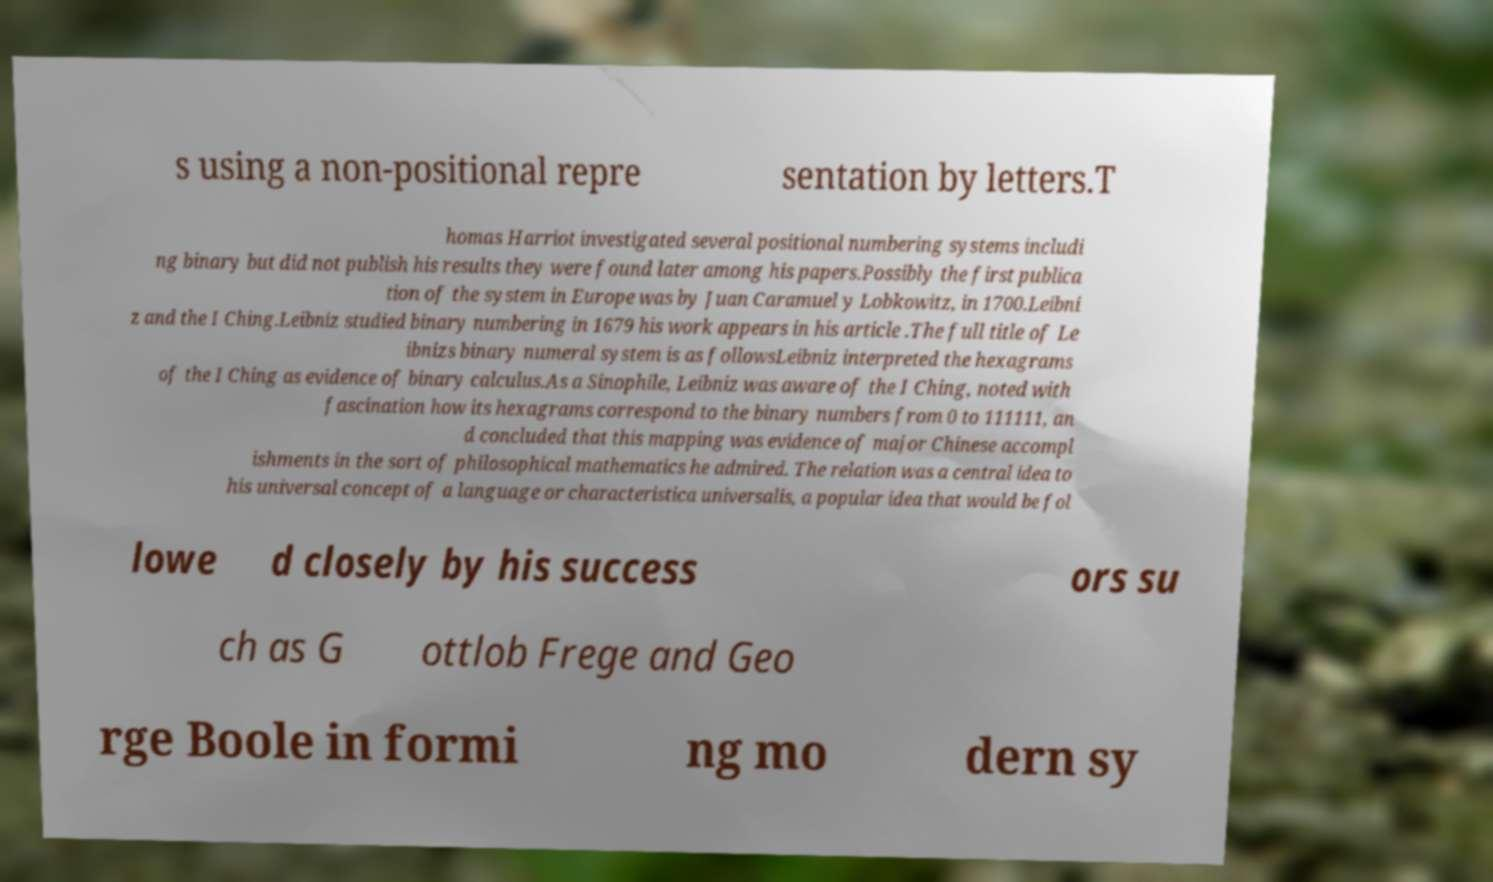Please read and relay the text visible in this image. What does it say? s using a non-positional repre sentation by letters.T homas Harriot investigated several positional numbering systems includi ng binary but did not publish his results they were found later among his papers.Possibly the first publica tion of the system in Europe was by Juan Caramuel y Lobkowitz, in 1700.Leibni z and the I Ching.Leibniz studied binary numbering in 1679 his work appears in his article .The full title of Le ibnizs binary numeral system is as followsLeibniz interpreted the hexagrams of the I Ching as evidence of binary calculus.As a Sinophile, Leibniz was aware of the I Ching, noted with fascination how its hexagrams correspond to the binary numbers from 0 to 111111, an d concluded that this mapping was evidence of major Chinese accompl ishments in the sort of philosophical mathematics he admired. The relation was a central idea to his universal concept of a language or characteristica universalis, a popular idea that would be fol lowe d closely by his success ors su ch as G ottlob Frege and Geo rge Boole in formi ng mo dern sy 